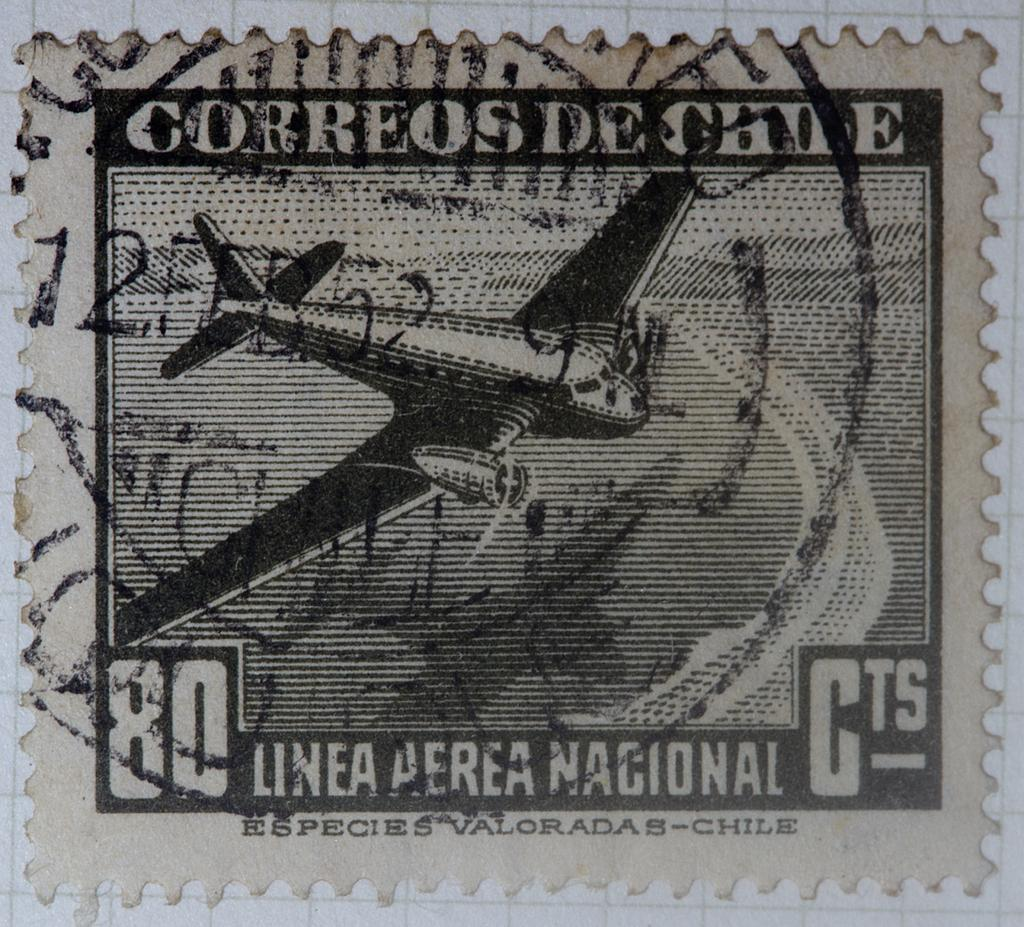What is the main object in the image? There is a stamp paper in the image. What is the stamp paper attached to? The stamp paper is attached to a white color surface. What time of day is it in the bedroom, as depicted in the image? There is no bedroom or indication of time of day in the image; it only shows a stamp paper attached to a white color surface. 